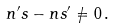Convert formula to latex. <formula><loc_0><loc_0><loc_500><loc_500>n ^ { \prime } s - n s ^ { \prime } \neq 0 \, .</formula> 